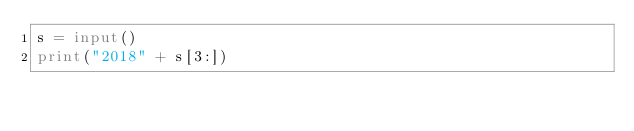Convert code to text. <code><loc_0><loc_0><loc_500><loc_500><_Python_>s = input()
print("2018" + s[3:])</code> 